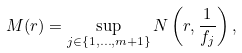Convert formula to latex. <formula><loc_0><loc_0><loc_500><loc_500>M ( r ) = \sup _ { j \in \{ 1 , \dots , m + 1 \} } N \left ( r , \frac { 1 } { f _ { j } } \right ) ,</formula> 